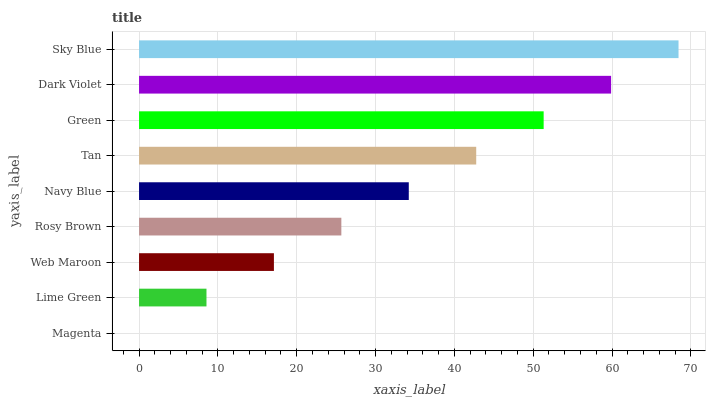Is Magenta the minimum?
Answer yes or no. Yes. Is Sky Blue the maximum?
Answer yes or no. Yes. Is Lime Green the minimum?
Answer yes or no. No. Is Lime Green the maximum?
Answer yes or no. No. Is Lime Green greater than Magenta?
Answer yes or no. Yes. Is Magenta less than Lime Green?
Answer yes or no. Yes. Is Magenta greater than Lime Green?
Answer yes or no. No. Is Lime Green less than Magenta?
Answer yes or no. No. Is Navy Blue the high median?
Answer yes or no. Yes. Is Navy Blue the low median?
Answer yes or no. Yes. Is Rosy Brown the high median?
Answer yes or no. No. Is Rosy Brown the low median?
Answer yes or no. No. 